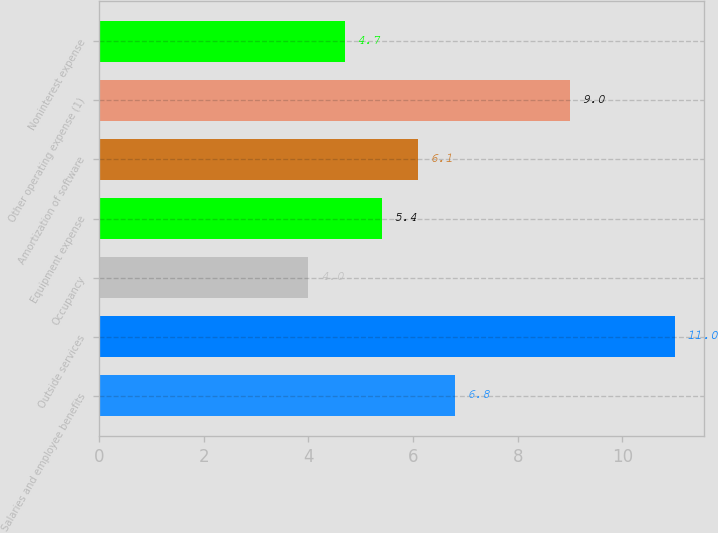<chart> <loc_0><loc_0><loc_500><loc_500><bar_chart><fcel>Salaries and employee benefits<fcel>Outside services<fcel>Occupancy<fcel>Equipment expense<fcel>Amortization of software<fcel>Other operating expense (1)<fcel>Noninterest expense<nl><fcel>6.8<fcel>11<fcel>4<fcel>5.4<fcel>6.1<fcel>9<fcel>4.7<nl></chart> 